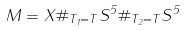Convert formula to latex. <formula><loc_0><loc_0><loc_500><loc_500>M = X \# _ { T _ { 1 } = T } { S } ^ { 5 } \# _ { T _ { 2 } = T } { S } ^ { 5 }</formula> 